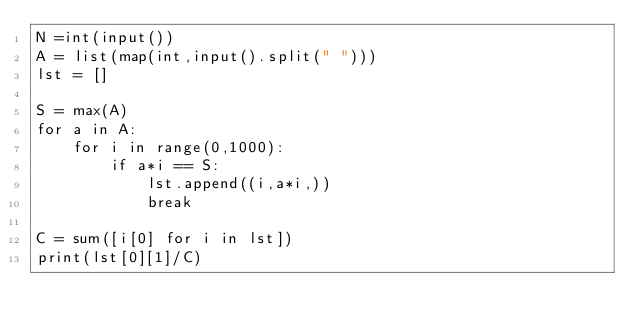Convert code to text. <code><loc_0><loc_0><loc_500><loc_500><_Python_>N =int(input())
A = list(map(int,input().split(" ")))
lst = []

S = max(A)
for a in A:
    for i in range(0,1000):
        if a*i == S:
            lst.append((i,a*i,))
            break

C = sum([i[0] for i in lst])
print(lst[0][1]/C)</code> 